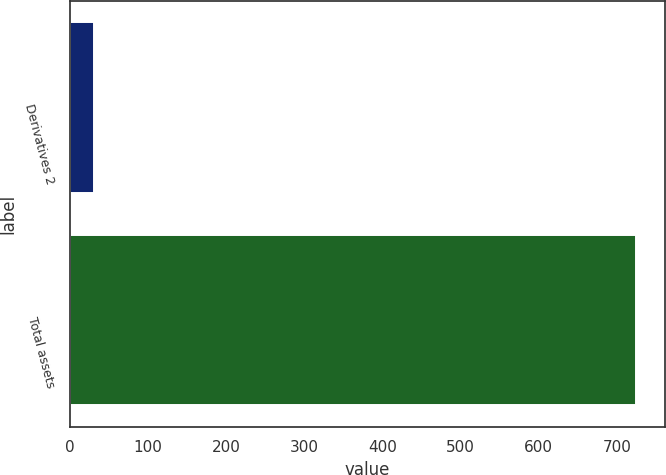<chart> <loc_0><loc_0><loc_500><loc_500><bar_chart><fcel>Derivatives 2<fcel>Total assets<nl><fcel>31<fcel>725<nl></chart> 